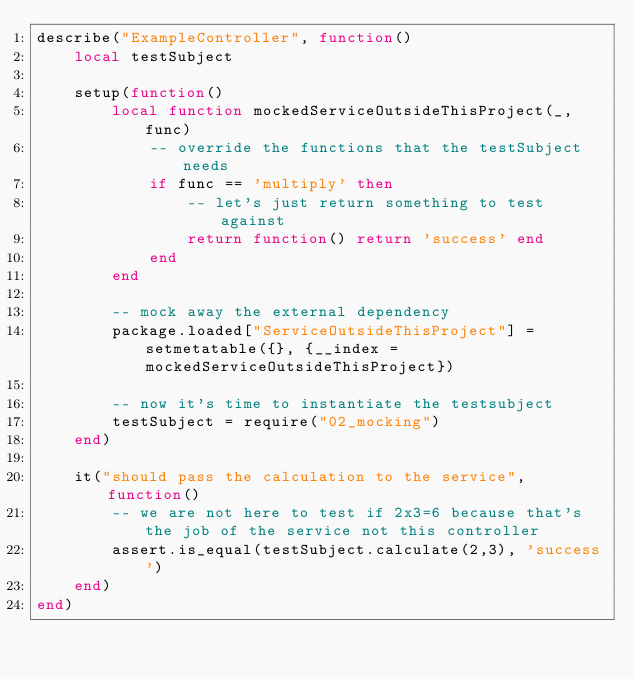Convert code to text. <code><loc_0><loc_0><loc_500><loc_500><_Lua_>describe("ExampleController", function()
    local testSubject

    setup(function()
        local function mockedServiceOutsideThisProject(_, func)
            -- override the functions that the testSubject needs
            if func == 'multiply' then
                -- let's just return something to test against
                return function() return 'success' end
            end
        end

        -- mock away the external dependency
        package.loaded["ServiceOutsideThisProject"] = setmetatable({}, {__index = mockedServiceOutsideThisProject})

        -- now it's time to instantiate the testsubject
        testSubject = require("02_mocking")
    end)

    it("should pass the calculation to the service", function()
        -- we are not here to test if 2x3=6 because that's the job of the service not this controller
        assert.is_equal(testSubject.calculate(2,3), 'success')
    end)
end)</code> 